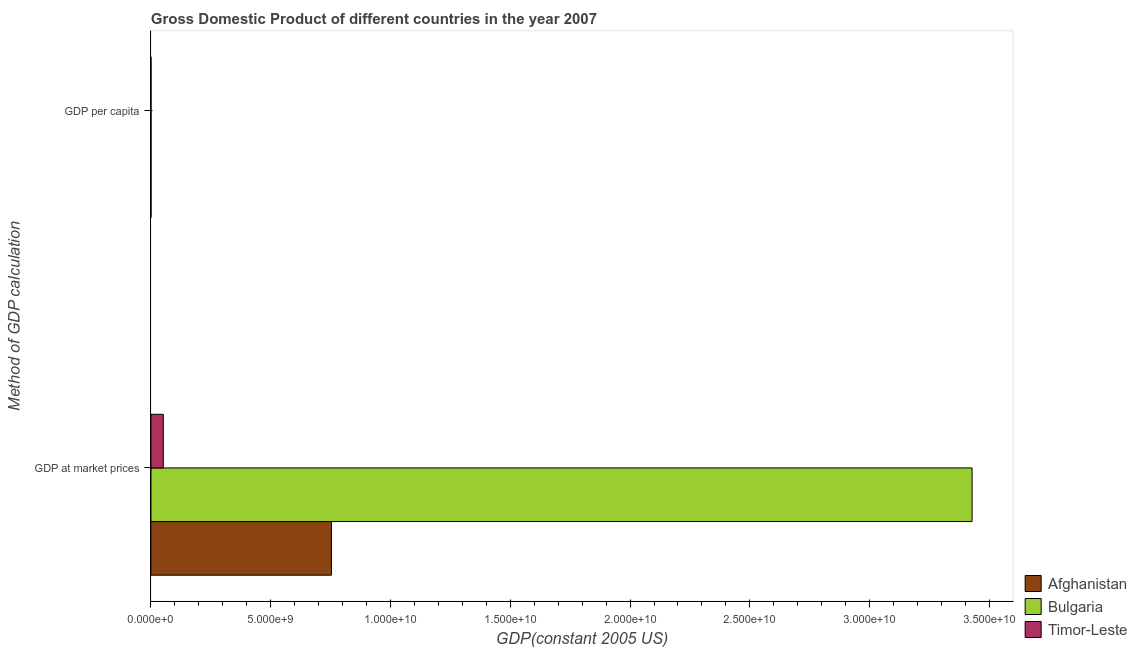How many different coloured bars are there?
Provide a short and direct response. 3. How many groups of bars are there?
Keep it short and to the point. 2. Are the number of bars per tick equal to the number of legend labels?
Your answer should be very brief. Yes. What is the label of the 1st group of bars from the top?
Offer a terse response. GDP per capita. What is the gdp at market prices in Afghanistan?
Make the answer very short. 7.53e+09. Across all countries, what is the maximum gdp per capita?
Your answer should be very brief. 4543.08. Across all countries, what is the minimum gdp at market prices?
Your response must be concise. 5.16e+08. In which country was the gdp per capita maximum?
Make the answer very short. Bulgaria. In which country was the gdp at market prices minimum?
Your answer should be very brief. Timor-Leste. What is the total gdp at market prices in the graph?
Make the answer very short. 4.23e+1. What is the difference between the gdp at market prices in Bulgaria and that in Afghanistan?
Make the answer very short. 2.67e+1. What is the difference between the gdp at market prices in Timor-Leste and the gdp per capita in Afghanistan?
Offer a terse response. 5.16e+08. What is the average gdp per capita per country?
Make the answer very short. 1781.14. What is the difference between the gdp at market prices and gdp per capita in Bulgaria?
Offer a terse response. 3.43e+1. What is the ratio of the gdp at market prices in Bulgaria to that in Timor-Leste?
Give a very brief answer. 66.44. Is the gdp at market prices in Afghanistan less than that in Bulgaria?
Give a very brief answer. Yes. What does the 1st bar from the top in GDP at market prices represents?
Your answer should be very brief. Timor-Leste. What does the 1st bar from the bottom in GDP at market prices represents?
Provide a succinct answer. Afghanistan. Are the values on the major ticks of X-axis written in scientific E-notation?
Ensure brevity in your answer.  Yes. Does the graph contain any zero values?
Provide a succinct answer. No. Does the graph contain grids?
Your answer should be compact. No. Where does the legend appear in the graph?
Your answer should be compact. Bottom right. What is the title of the graph?
Keep it short and to the point. Gross Domestic Product of different countries in the year 2007. What is the label or title of the X-axis?
Make the answer very short. GDP(constant 2005 US). What is the label or title of the Y-axis?
Your response must be concise. Method of GDP calculation. What is the GDP(constant 2005 US) of Afghanistan in GDP at market prices?
Make the answer very short. 7.53e+09. What is the GDP(constant 2005 US) in Bulgaria in GDP at market prices?
Provide a succinct answer. 3.43e+1. What is the GDP(constant 2005 US) of Timor-Leste in GDP at market prices?
Provide a short and direct response. 5.16e+08. What is the GDP(constant 2005 US) in Afghanistan in GDP per capita?
Make the answer very short. 291.13. What is the GDP(constant 2005 US) in Bulgaria in GDP per capita?
Make the answer very short. 4543.08. What is the GDP(constant 2005 US) of Timor-Leste in GDP per capita?
Give a very brief answer. 509.22. Across all Method of GDP calculation, what is the maximum GDP(constant 2005 US) of Afghanistan?
Provide a short and direct response. 7.53e+09. Across all Method of GDP calculation, what is the maximum GDP(constant 2005 US) of Bulgaria?
Your answer should be very brief. 3.43e+1. Across all Method of GDP calculation, what is the maximum GDP(constant 2005 US) in Timor-Leste?
Your answer should be compact. 5.16e+08. Across all Method of GDP calculation, what is the minimum GDP(constant 2005 US) in Afghanistan?
Give a very brief answer. 291.13. Across all Method of GDP calculation, what is the minimum GDP(constant 2005 US) in Bulgaria?
Offer a terse response. 4543.08. Across all Method of GDP calculation, what is the minimum GDP(constant 2005 US) of Timor-Leste?
Your answer should be compact. 509.22. What is the total GDP(constant 2005 US) of Afghanistan in the graph?
Make the answer very short. 7.53e+09. What is the total GDP(constant 2005 US) in Bulgaria in the graph?
Your answer should be very brief. 3.43e+1. What is the total GDP(constant 2005 US) of Timor-Leste in the graph?
Make the answer very short. 5.16e+08. What is the difference between the GDP(constant 2005 US) in Afghanistan in GDP at market prices and that in GDP per capita?
Provide a short and direct response. 7.53e+09. What is the difference between the GDP(constant 2005 US) in Bulgaria in GDP at market prices and that in GDP per capita?
Provide a succinct answer. 3.43e+1. What is the difference between the GDP(constant 2005 US) of Timor-Leste in GDP at market prices and that in GDP per capita?
Keep it short and to the point. 5.16e+08. What is the difference between the GDP(constant 2005 US) of Afghanistan in GDP at market prices and the GDP(constant 2005 US) of Bulgaria in GDP per capita?
Keep it short and to the point. 7.53e+09. What is the difference between the GDP(constant 2005 US) in Afghanistan in GDP at market prices and the GDP(constant 2005 US) in Timor-Leste in GDP per capita?
Ensure brevity in your answer.  7.53e+09. What is the difference between the GDP(constant 2005 US) of Bulgaria in GDP at market prices and the GDP(constant 2005 US) of Timor-Leste in GDP per capita?
Give a very brief answer. 3.43e+1. What is the average GDP(constant 2005 US) of Afghanistan per Method of GDP calculation?
Your response must be concise. 3.77e+09. What is the average GDP(constant 2005 US) in Bulgaria per Method of GDP calculation?
Ensure brevity in your answer.  1.71e+1. What is the average GDP(constant 2005 US) in Timor-Leste per Method of GDP calculation?
Give a very brief answer. 2.58e+08. What is the difference between the GDP(constant 2005 US) of Afghanistan and GDP(constant 2005 US) of Bulgaria in GDP at market prices?
Keep it short and to the point. -2.67e+1. What is the difference between the GDP(constant 2005 US) of Afghanistan and GDP(constant 2005 US) of Timor-Leste in GDP at market prices?
Your response must be concise. 7.02e+09. What is the difference between the GDP(constant 2005 US) of Bulgaria and GDP(constant 2005 US) of Timor-Leste in GDP at market prices?
Keep it short and to the point. 3.38e+1. What is the difference between the GDP(constant 2005 US) in Afghanistan and GDP(constant 2005 US) in Bulgaria in GDP per capita?
Give a very brief answer. -4251.95. What is the difference between the GDP(constant 2005 US) of Afghanistan and GDP(constant 2005 US) of Timor-Leste in GDP per capita?
Offer a very short reply. -218.09. What is the difference between the GDP(constant 2005 US) of Bulgaria and GDP(constant 2005 US) of Timor-Leste in GDP per capita?
Your answer should be compact. 4033.86. What is the ratio of the GDP(constant 2005 US) of Afghanistan in GDP at market prices to that in GDP per capita?
Give a very brief answer. 2.59e+07. What is the ratio of the GDP(constant 2005 US) of Bulgaria in GDP at market prices to that in GDP per capita?
Provide a succinct answer. 7.55e+06. What is the ratio of the GDP(constant 2005 US) in Timor-Leste in GDP at market prices to that in GDP per capita?
Your response must be concise. 1.01e+06. What is the difference between the highest and the second highest GDP(constant 2005 US) in Afghanistan?
Offer a very short reply. 7.53e+09. What is the difference between the highest and the second highest GDP(constant 2005 US) in Bulgaria?
Provide a succinct answer. 3.43e+1. What is the difference between the highest and the second highest GDP(constant 2005 US) in Timor-Leste?
Offer a very short reply. 5.16e+08. What is the difference between the highest and the lowest GDP(constant 2005 US) in Afghanistan?
Your response must be concise. 7.53e+09. What is the difference between the highest and the lowest GDP(constant 2005 US) in Bulgaria?
Offer a terse response. 3.43e+1. What is the difference between the highest and the lowest GDP(constant 2005 US) in Timor-Leste?
Provide a short and direct response. 5.16e+08. 